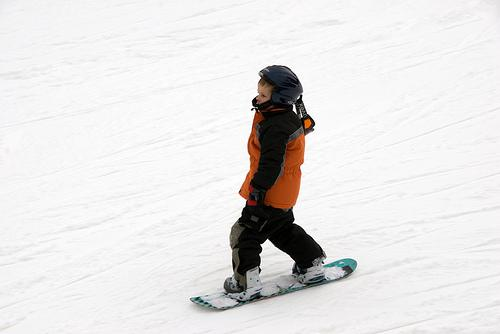Question: what is on the boys head?
Choices:
A. Hat.
B. Helmet.
C. Bandage.
D. Santa hat.
Answer with the letter. Answer: B Question: when is the picture taken?
Choices:
A. Winter.
B. Summer.
C. Christmas.
D. Fall.
Answer with the letter. Answer: A Question: where is the snow?
Choices:
A. On the curb.
B. On the car.
C. On the ground.
D. In the window.
Answer with the letter. Answer: C Question: why is the boy wearing a helmet?
Choices:
A. It is the law.
B. Safety.
C. He was forced to.
D. For fashion.
Answer with the letter. Answer: B Question: who is in the picture?
Choices:
A. A boy.
B. A girl.
C. A baby.
D. An elderly couple.
Answer with the letter. Answer: A Question: what is the boy doing?
Choices:
A. Snowboarding.
B. Jumping jacks.
C. Shaving his head.
D. Playing video games.
Answer with the letter. Answer: A 